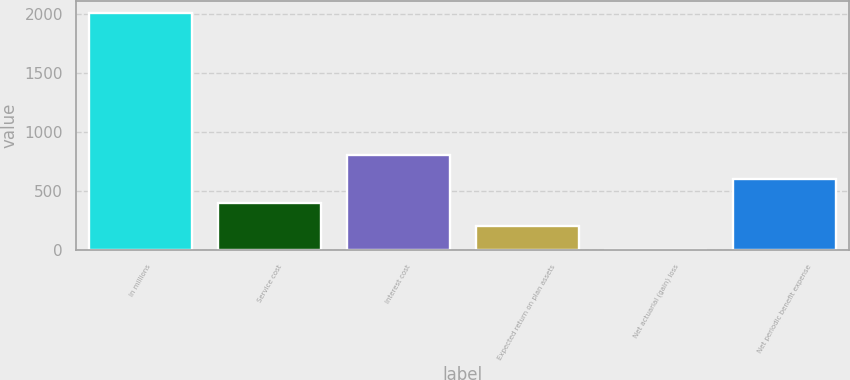<chart> <loc_0><loc_0><loc_500><loc_500><bar_chart><fcel>In millions<fcel>Service cost<fcel>Interest cost<fcel>Expected return on plan assets<fcel>Net actuarial (gain) loss<fcel>Net periodic benefit expense<nl><fcel>2014<fcel>405.28<fcel>807.46<fcel>204.19<fcel>3.1<fcel>606.37<nl></chart> 